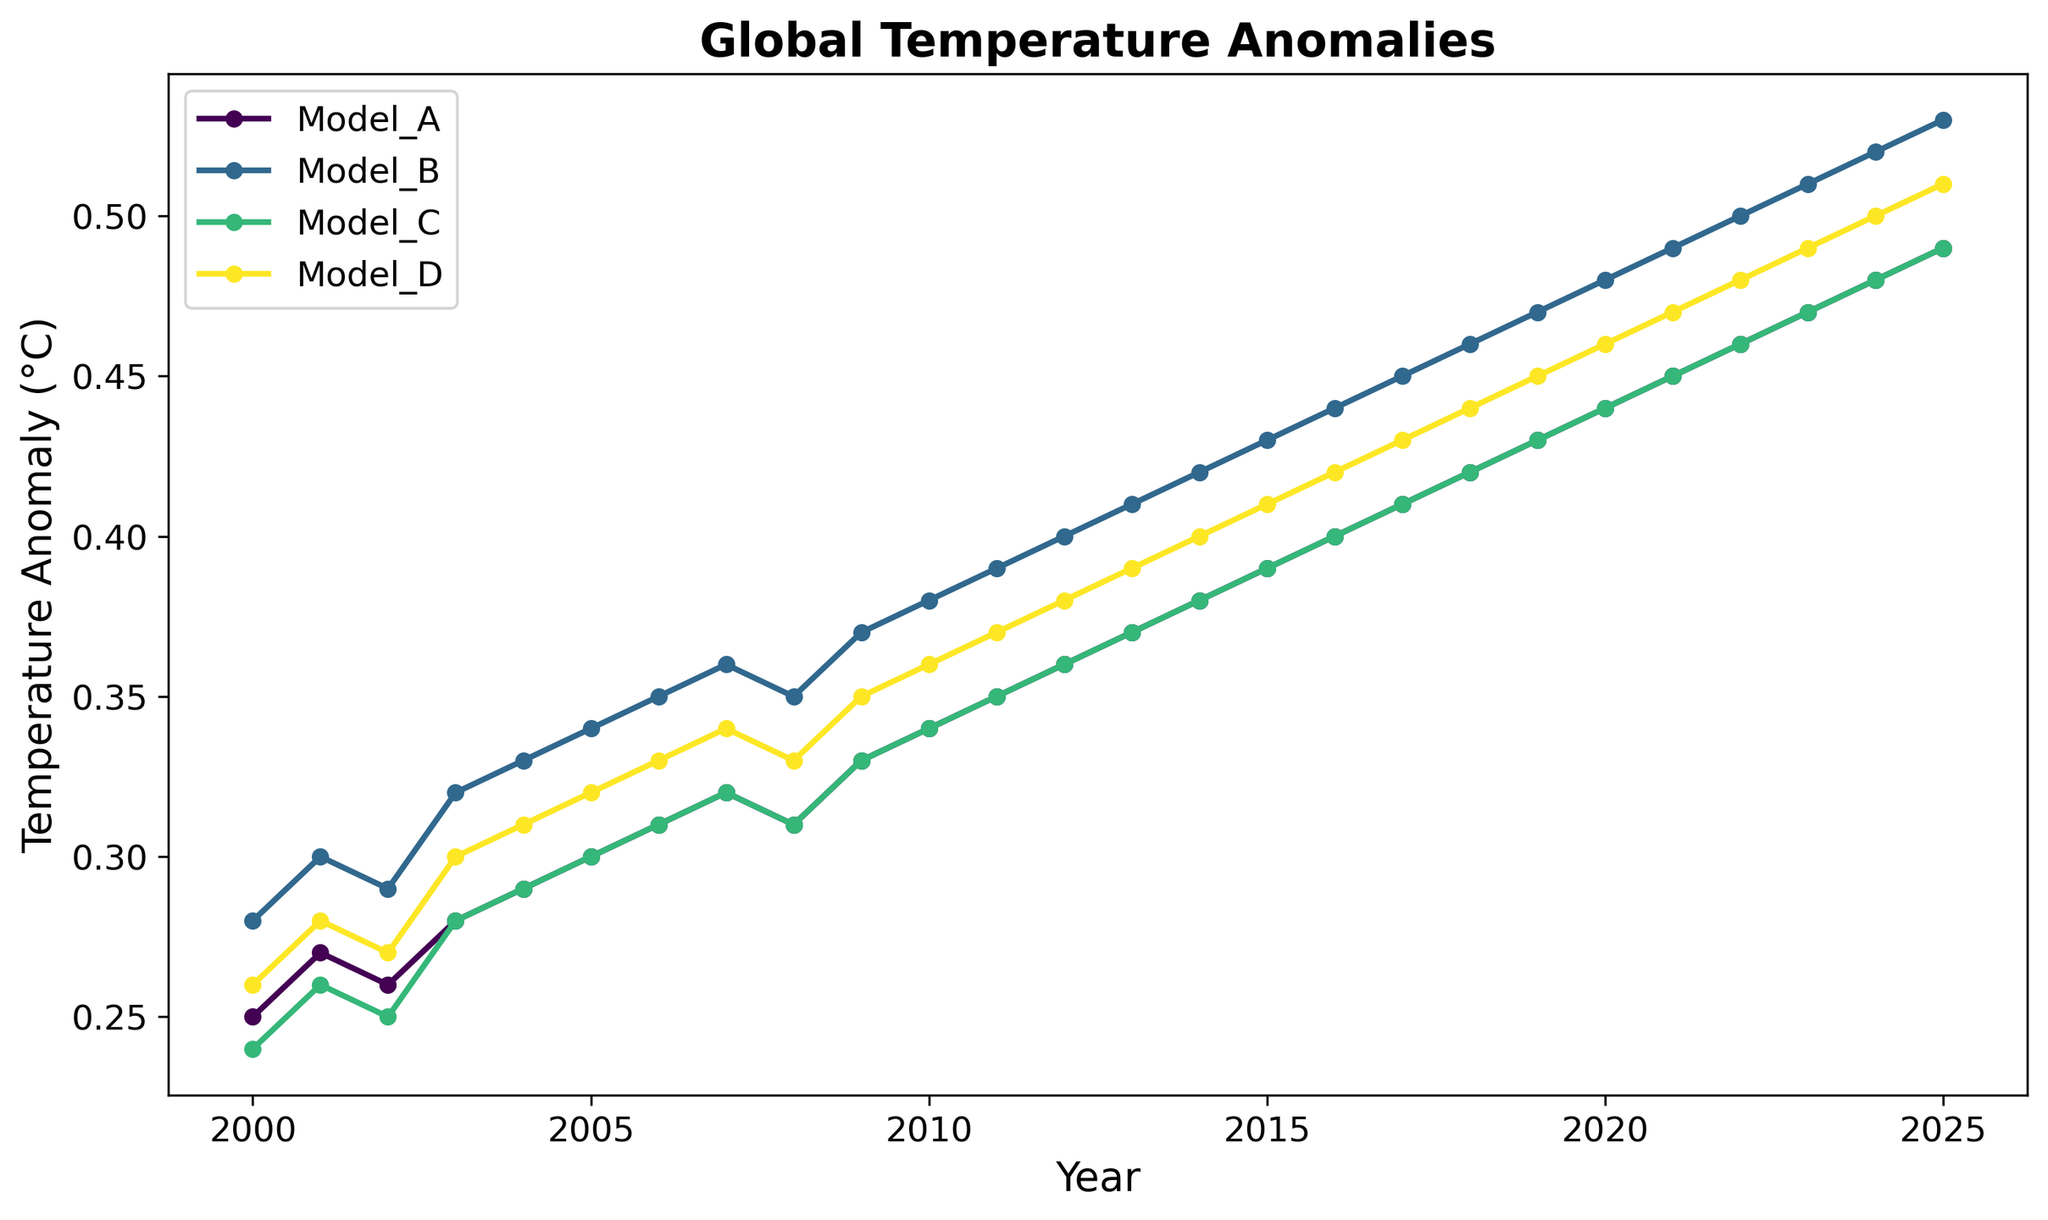What's the overall trend in global temperature anomalies from 2000 to 2025 for Model_A? The trend is visualized by observing the slope of the line representing Model_A, which appears to steadily increase from 0.25°C in 2000 to 0.49°C in 2025.
Answer: Steadily increasing Which model shows the highest temperature anomaly in 2015? By referring to the data points for 2015 in the figure, we see Model_B reaches 0.43°C, which is higher than the other models for that year.
Answer: Model_B Are the temperature anomalies for Model_A and Model_D equal at any point? By examining the lines for Model_A and Model_D, we observe that they never intersect or show identical values at any year.
Answer: No What is the difference between the highest and lowest temperature anomaly in 2020? The highest anomaly in 2020 is from Model_B at 0.48°C, and the lowest is Model_A at 0.44°C. The difference is 0.48°C - 0.44°C = 0.04°C.
Answer: 0.04°C Which year shows the largest increase in temperature anomaly for Model_C compared to the previous year? By checking the increments year by year for Model_C, the largest increase occurs between 2002 (0.25°C) and 2003 (0.28°C), an increase of 0.03°C.
Answer: 2003 Which model has the steepest slope indicating the most rapid increase in temperature anomalies? Visual inspection of the lines' slopes indicates that Model_B has the steepest slope, showing the most rapid increase over the examined period.
Answer: Model_B What is the average temperature anomaly for Model_D over the entire period? Summing up all values for Model_D and dividing by the number of years (26): (0.26 + 0.28 + ... + 0.50 + 0.51)/26 = 0.366
Answer: 0.366 Between 2005 and 2010, which model shows the smallest variation in temperature anomalies? By evaluating the variation (range) for each model from 2005 to 2010, Model_C varies between 0.30°C and 0.34°C, a range of 0.04°C, which is smaller compared to others.
Answer: Model_C 